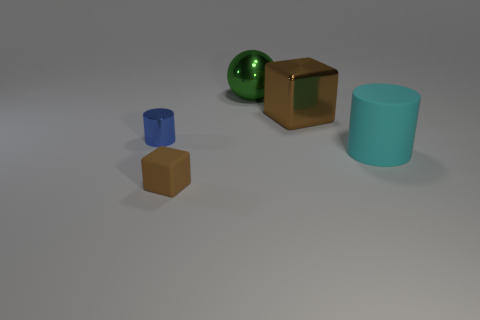What color is the block right of the object that is in front of the thing on the right side of the brown shiny thing?
Your answer should be very brief. Brown. Does the big metallic block have the same color as the tiny rubber block?
Your response must be concise. Yes. What number of metallic spheres are the same size as the cyan matte cylinder?
Provide a short and direct response. 1. Is the number of big green things that are behind the cyan object greater than the number of tiny brown blocks to the left of the tiny metal cylinder?
Your answer should be very brief. Yes. The cylinder that is left of the big shiny object right of the big green object is what color?
Keep it short and to the point. Blue. Does the big cylinder have the same material as the small brown cube?
Make the answer very short. Yes. Is there a big object of the same shape as the small brown object?
Your answer should be compact. Yes. There is a cube in front of the big cube; is its color the same as the big metal block?
Your response must be concise. Yes. There is a brown thing that is in front of the cyan cylinder; is its size the same as the rubber thing right of the large green sphere?
Offer a terse response. No. What is the size of the other thing that is made of the same material as the tiny brown thing?
Your response must be concise. Large. 